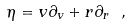Convert formula to latex. <formula><loc_0><loc_0><loc_500><loc_500>\eta = v \partial _ { v } + r \partial _ { r } \ ,</formula> 